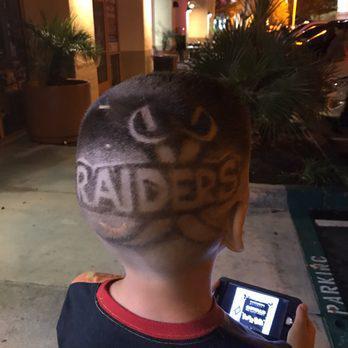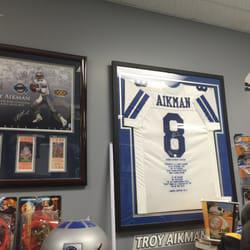The first image is the image on the left, the second image is the image on the right. Evaluate the accuracy of this statement regarding the images: "In at least one image there are two boys side by side in a barber shop.". Is it true? Answer yes or no. No. The first image is the image on the left, the second image is the image on the right. Evaluate the accuracy of this statement regarding the images: "An image shows two young boys standing side-by-side and facing forward.". Is it true? Answer yes or no. No. 